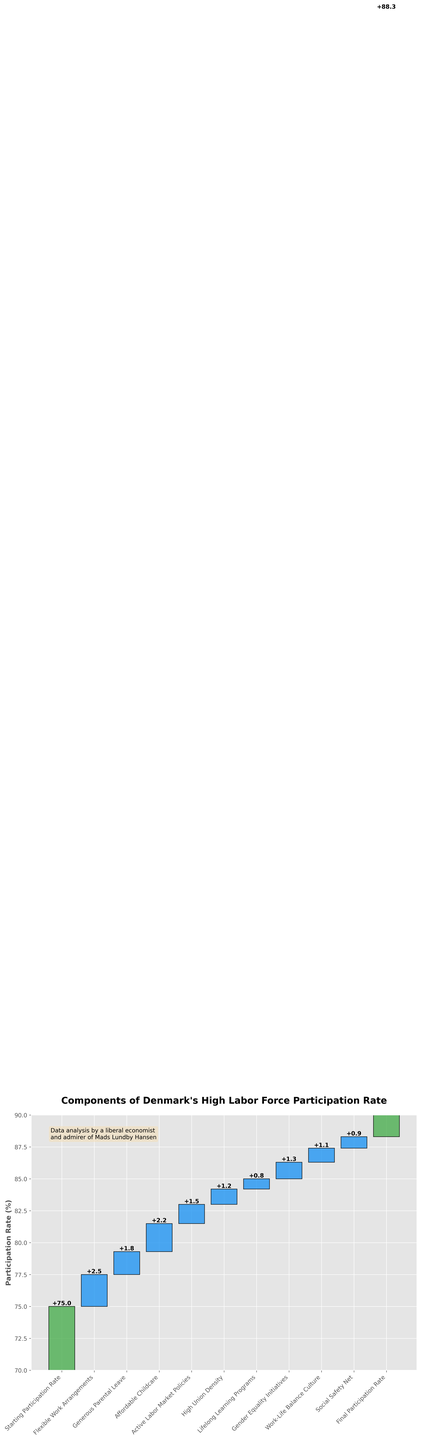What is the title of the figure? The title of the figure is shown at the top of the plot. By observing, it reads "Components of Denmark's High Labor Force Participation Rate".
Answer: Components of Denmark's High Labor Force Participation Rate What is the starting labor force participation rate shown in the chart? The starting labor force participation rate is labeled as the first category on the x-axis. It is marked with the value of 75%.
Answer: 75% Which category contributes the most to increasing the labor force participation rate? To find the category with the largest increase, look for the bar with the largest positive value. The chart shows that "Flexible Work Arrangements" has the largest increase with a value of 2.5%.
Answer: Flexible Work Arrangements What is the final participation rate in the chart? The final participation rate is the last bar category on the x-axis. It is marked with the value of 88.3%.
Answer: 88.3% How many categories are shown in the chart from start to end? Count all the unique categories on the x-axis from the first to the last. The total number of categories listed is 11.
Answer: 11 How much does "Active Labor Market Policies" contribute to the labor force participation rate? Look at the value associated with the "Active Labor Market Policies" category on the x-axis. The contribution is shown as 1.5%.
Answer: 1.5% By how much does "Lifelong Learning Programs" increase the labor force participation rate? The value associated with "Lifelong Learning Programs" on the x-axis indicates its contribution. It increases the rate by 0.8%.
Answer: 0.8% What is the combined contribution of "Affordable Childcare" and "Gender Equality Initiatives" to the labor force participation rate? Add the values of both categories: "Affordable Childcare" contributes 2.2%, and "Gender Equality Initiatives" contributes 1.3%. Therefore, the combined contribution is 2.2% + 1.3% = 3.5%.
Answer: 3.5% Does "High Union Density" contribute more or less than "Social Safety Net"? Compare the values of "High Union Density" (1.2%) and "Social Safety Net" (0.9%). High Union Density contributes more than Social Safety Net.
Answer: High Union Density contributes more What total percentage increase in the labor force participation rate is contributed by the "Work-Life Balance Culture" and "Social Safety Net"? Add the values for both categories. "Work-Life Balance Culture" contributes 1.1%, and "Social Safety Net" contributes 0.9%. The total increase is 1.1% + 0.9% = 2.0%.
Answer: 2.0% 